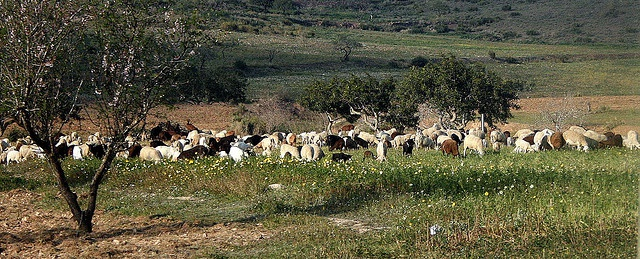Describe the objects in this image and their specific colors. I can see cow in darkgreen, black, tan, gray, and olive tones, sheep in darkgreen, black, tan, ivory, and gray tones, cow in darkgreen, black, gray, and ivory tones, sheep in darkgreen, khaki, beige, black, and tan tones, and cow in darkgreen, tan, beige, and black tones in this image. 